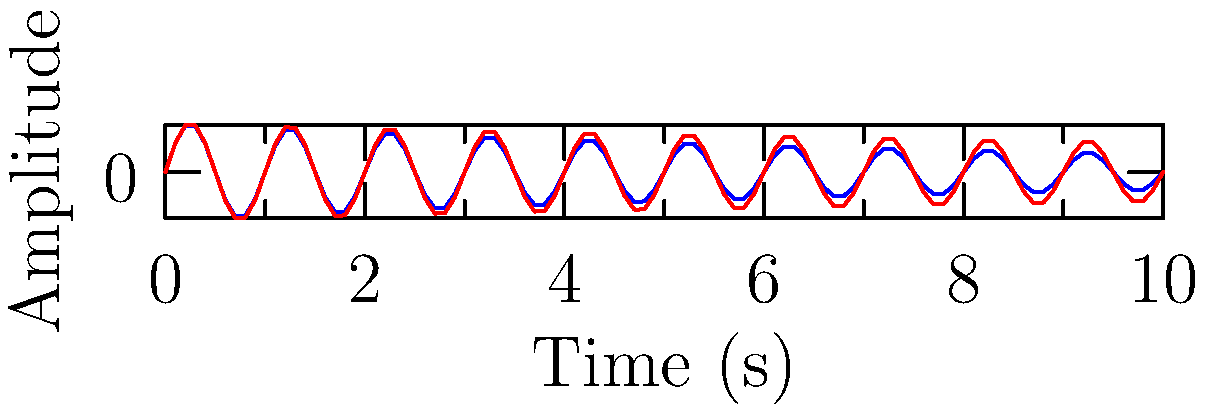The sound wave diagram shows the acoustic properties of two different monastic chanting spaces. Which space (A or B) has a longer reverberation time, and how does this affect the perception of chants in that space? To answer this question, we need to analyze the sound wave diagrams for spaces A and B:

1. Observe the decay rates:
   - Space A (blue): The amplitude decreases more rapidly over time.
   - Space B (red): The amplitude decreases more slowly over time.

2. Understand reverberation time:
   - Reverberation time is the time it takes for sound to decay to inaudibility after the source stops.
   - Longer reverberation time means sound persists longer in the space.

3. Compare the graphs:
   - Space B's sound wave decays more slowly, indicating a longer reverberation time.

4. Effects on chant perception:
   - Longer reverberation time (Space B) results in:
     a) Increased sense of spaciousness
     b) Enhanced blending of voices
     c) Prolonged resonance of each note
     d) Potential loss of clarity in fast-paced chants

5. Conclusion:
   - Space B has a longer reverberation time, creating a more reverberant environment for chanting.
Answer: Space B; longer reverberation enhances spaciousness and blending but may reduce clarity. 